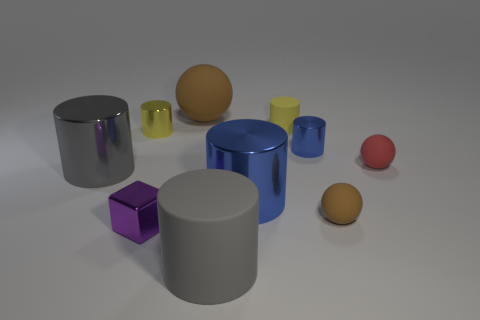Subtract all big shiny cylinders. How many cylinders are left? 4 Subtract all yellow cylinders. How many cylinders are left? 4 Subtract all gray cylinders. Subtract all yellow blocks. How many cylinders are left? 4 Subtract all cubes. How many objects are left? 9 Subtract all small purple objects. Subtract all large cyan things. How many objects are left? 9 Add 9 small blue metallic cylinders. How many small blue metallic cylinders are left? 10 Add 5 small red metallic things. How many small red metallic things exist? 5 Subtract 0 blue blocks. How many objects are left? 10 